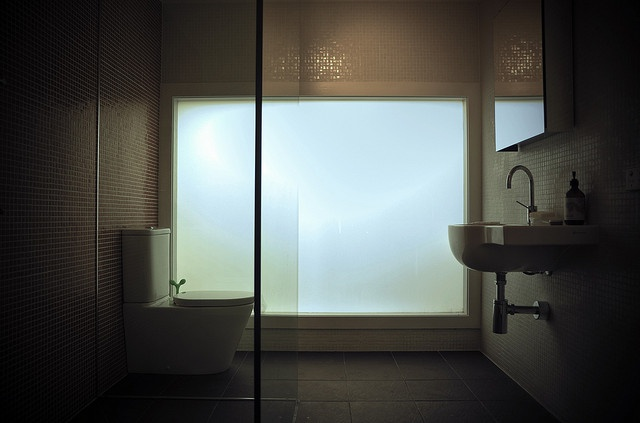Describe the objects in this image and their specific colors. I can see toilet in black, gray, and darkgray tones, sink in black and gray tones, and bottle in black and gray tones in this image. 